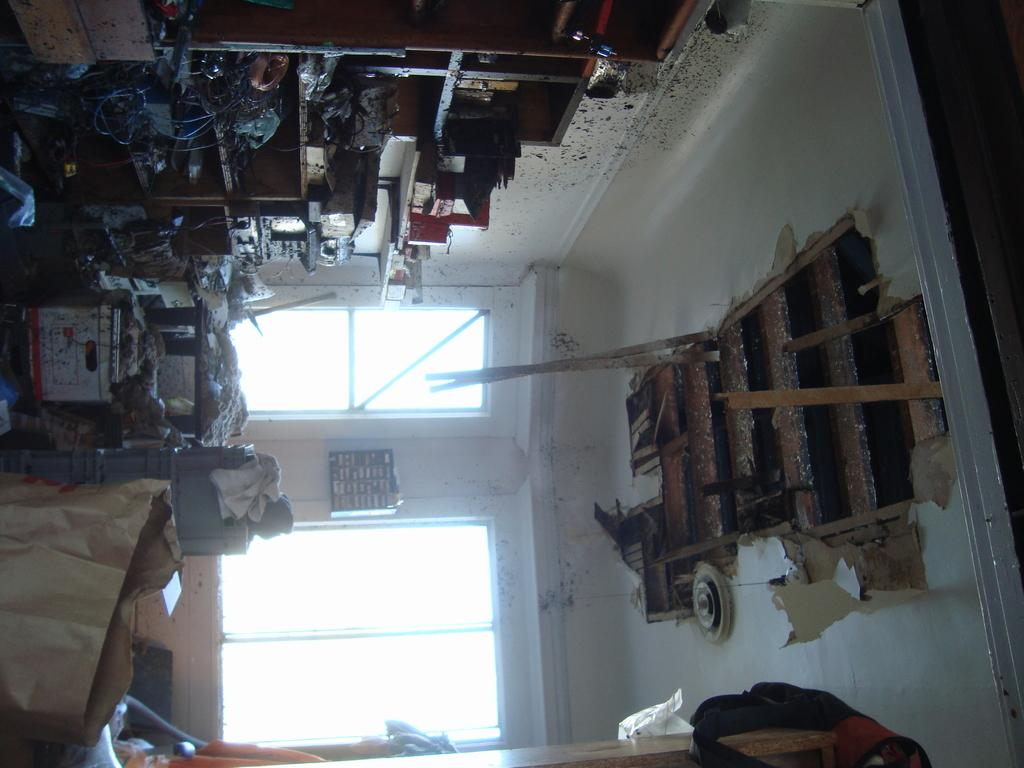What is placed on the floor in the image? There are objects placed on the floor in the image. What type of furniture can be seen in the image? There are cupboards in the image. Can you describe the condition of the ceiling in the image? The ceiling appears to be damaged in the image. What can be seen in the background of the image? There are glass windows visible in the background of the image. What is the name of the nation that is depicted in the image? There is no nation depicted in the image; it is a room with objects, cupboards, a damaged ceiling, and glass windows. How quiet is the room in the image? The image does not provide any information about the noise level in the room, so it cannot be determined from the image. 